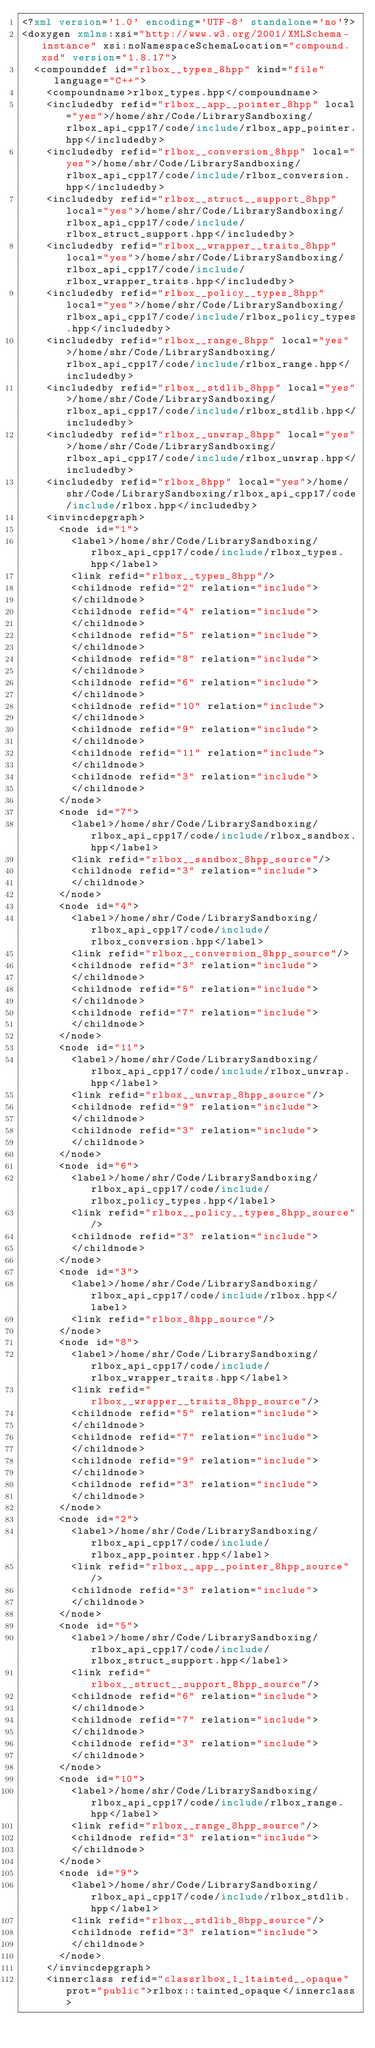<code> <loc_0><loc_0><loc_500><loc_500><_XML_><?xml version='1.0' encoding='UTF-8' standalone='no'?>
<doxygen xmlns:xsi="http://www.w3.org/2001/XMLSchema-instance" xsi:noNamespaceSchemaLocation="compound.xsd" version="1.8.17">
  <compounddef id="rlbox__types_8hpp" kind="file" language="C++">
    <compoundname>rlbox_types.hpp</compoundname>
    <includedby refid="rlbox__app__pointer_8hpp" local="yes">/home/shr/Code/LibrarySandboxing/rlbox_api_cpp17/code/include/rlbox_app_pointer.hpp</includedby>
    <includedby refid="rlbox__conversion_8hpp" local="yes">/home/shr/Code/LibrarySandboxing/rlbox_api_cpp17/code/include/rlbox_conversion.hpp</includedby>
    <includedby refid="rlbox__struct__support_8hpp" local="yes">/home/shr/Code/LibrarySandboxing/rlbox_api_cpp17/code/include/rlbox_struct_support.hpp</includedby>
    <includedby refid="rlbox__wrapper__traits_8hpp" local="yes">/home/shr/Code/LibrarySandboxing/rlbox_api_cpp17/code/include/rlbox_wrapper_traits.hpp</includedby>
    <includedby refid="rlbox__policy__types_8hpp" local="yes">/home/shr/Code/LibrarySandboxing/rlbox_api_cpp17/code/include/rlbox_policy_types.hpp</includedby>
    <includedby refid="rlbox__range_8hpp" local="yes">/home/shr/Code/LibrarySandboxing/rlbox_api_cpp17/code/include/rlbox_range.hpp</includedby>
    <includedby refid="rlbox__stdlib_8hpp" local="yes">/home/shr/Code/LibrarySandboxing/rlbox_api_cpp17/code/include/rlbox_stdlib.hpp</includedby>
    <includedby refid="rlbox__unwrap_8hpp" local="yes">/home/shr/Code/LibrarySandboxing/rlbox_api_cpp17/code/include/rlbox_unwrap.hpp</includedby>
    <includedby refid="rlbox_8hpp" local="yes">/home/shr/Code/LibrarySandboxing/rlbox_api_cpp17/code/include/rlbox.hpp</includedby>
    <invincdepgraph>
      <node id="1">
        <label>/home/shr/Code/LibrarySandboxing/rlbox_api_cpp17/code/include/rlbox_types.hpp</label>
        <link refid="rlbox__types_8hpp"/>
        <childnode refid="2" relation="include">
        </childnode>
        <childnode refid="4" relation="include">
        </childnode>
        <childnode refid="5" relation="include">
        </childnode>
        <childnode refid="8" relation="include">
        </childnode>
        <childnode refid="6" relation="include">
        </childnode>
        <childnode refid="10" relation="include">
        </childnode>
        <childnode refid="9" relation="include">
        </childnode>
        <childnode refid="11" relation="include">
        </childnode>
        <childnode refid="3" relation="include">
        </childnode>
      </node>
      <node id="7">
        <label>/home/shr/Code/LibrarySandboxing/rlbox_api_cpp17/code/include/rlbox_sandbox.hpp</label>
        <link refid="rlbox__sandbox_8hpp_source"/>
        <childnode refid="3" relation="include">
        </childnode>
      </node>
      <node id="4">
        <label>/home/shr/Code/LibrarySandboxing/rlbox_api_cpp17/code/include/rlbox_conversion.hpp</label>
        <link refid="rlbox__conversion_8hpp_source"/>
        <childnode refid="3" relation="include">
        </childnode>
        <childnode refid="5" relation="include">
        </childnode>
        <childnode refid="7" relation="include">
        </childnode>
      </node>
      <node id="11">
        <label>/home/shr/Code/LibrarySandboxing/rlbox_api_cpp17/code/include/rlbox_unwrap.hpp</label>
        <link refid="rlbox__unwrap_8hpp_source"/>
        <childnode refid="9" relation="include">
        </childnode>
        <childnode refid="3" relation="include">
        </childnode>
      </node>
      <node id="6">
        <label>/home/shr/Code/LibrarySandboxing/rlbox_api_cpp17/code/include/rlbox_policy_types.hpp</label>
        <link refid="rlbox__policy__types_8hpp_source"/>
        <childnode refid="3" relation="include">
        </childnode>
      </node>
      <node id="3">
        <label>/home/shr/Code/LibrarySandboxing/rlbox_api_cpp17/code/include/rlbox.hpp</label>
        <link refid="rlbox_8hpp_source"/>
      </node>
      <node id="8">
        <label>/home/shr/Code/LibrarySandboxing/rlbox_api_cpp17/code/include/rlbox_wrapper_traits.hpp</label>
        <link refid="rlbox__wrapper__traits_8hpp_source"/>
        <childnode refid="5" relation="include">
        </childnode>
        <childnode refid="7" relation="include">
        </childnode>
        <childnode refid="9" relation="include">
        </childnode>
        <childnode refid="3" relation="include">
        </childnode>
      </node>
      <node id="2">
        <label>/home/shr/Code/LibrarySandboxing/rlbox_api_cpp17/code/include/rlbox_app_pointer.hpp</label>
        <link refid="rlbox__app__pointer_8hpp_source"/>
        <childnode refid="3" relation="include">
        </childnode>
      </node>
      <node id="5">
        <label>/home/shr/Code/LibrarySandboxing/rlbox_api_cpp17/code/include/rlbox_struct_support.hpp</label>
        <link refid="rlbox__struct__support_8hpp_source"/>
        <childnode refid="6" relation="include">
        </childnode>
        <childnode refid="7" relation="include">
        </childnode>
        <childnode refid="3" relation="include">
        </childnode>
      </node>
      <node id="10">
        <label>/home/shr/Code/LibrarySandboxing/rlbox_api_cpp17/code/include/rlbox_range.hpp</label>
        <link refid="rlbox__range_8hpp_source"/>
        <childnode refid="3" relation="include">
        </childnode>
      </node>
      <node id="9">
        <label>/home/shr/Code/LibrarySandboxing/rlbox_api_cpp17/code/include/rlbox_stdlib.hpp</label>
        <link refid="rlbox__stdlib_8hpp_source"/>
        <childnode refid="3" relation="include">
        </childnode>
      </node>
    </invincdepgraph>
    <innerclass refid="classrlbox_1_1tainted__opaque" prot="public">rlbox::tainted_opaque</innerclass></code> 